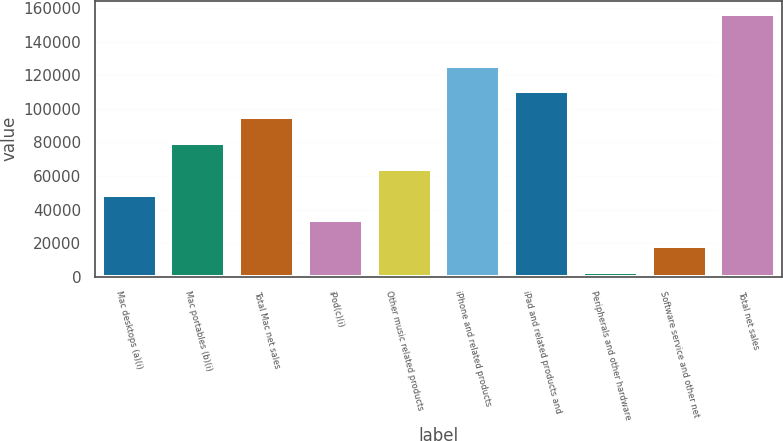Convert chart. <chart><loc_0><loc_0><loc_500><loc_500><bar_chart><fcel>Mac desktops (a)(i)<fcel>Mac portables (b)(i)<fcel>Total Mac net sales<fcel>iPod(c)(i)<fcel>Other music related products<fcel>iPhone and related products<fcel>iPad and related products and<fcel>Peripherals and other hardware<fcel>Software service and other net<fcel>Total net sales<nl><fcel>48897<fcel>79643<fcel>95016<fcel>33524<fcel>64270<fcel>125762<fcel>110389<fcel>2778<fcel>18151<fcel>156508<nl></chart> 